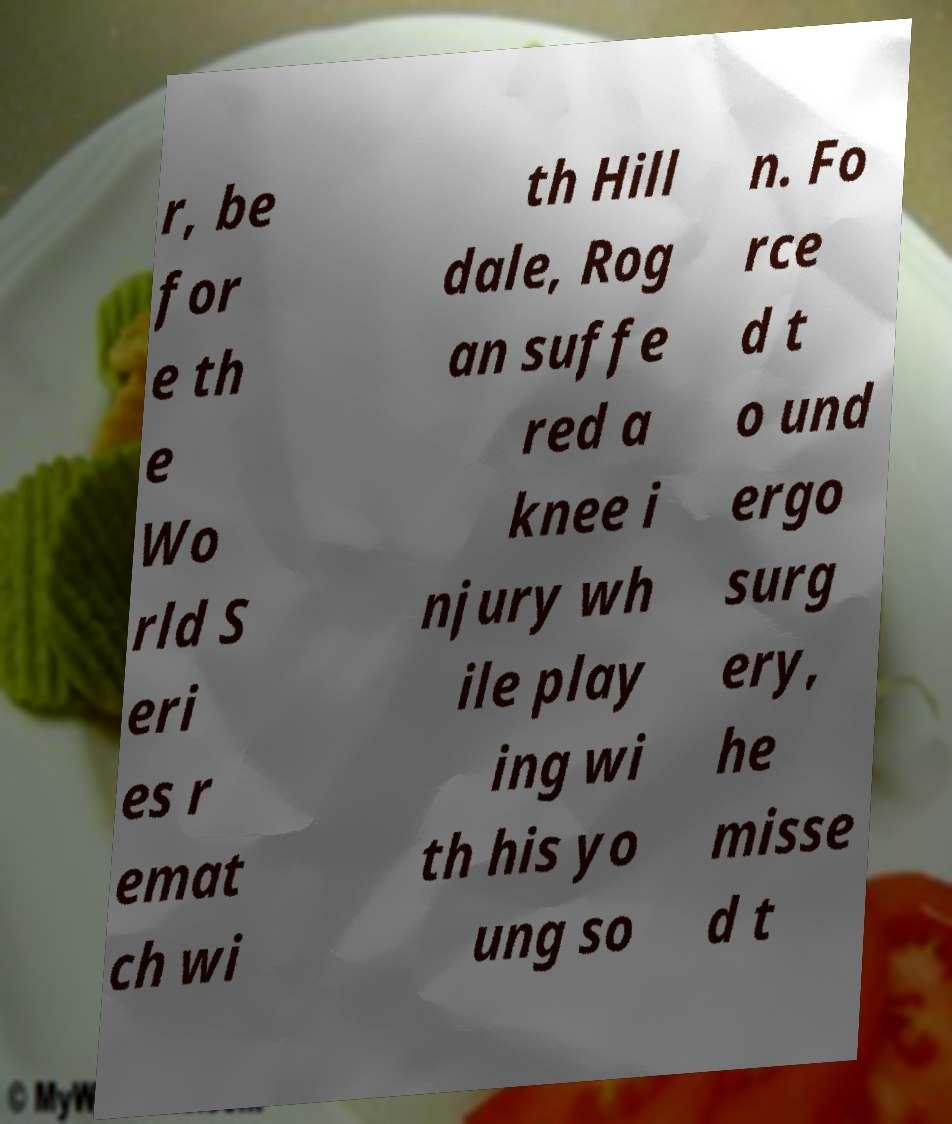Can you accurately transcribe the text from the provided image for me? r, be for e th e Wo rld S eri es r emat ch wi th Hill dale, Rog an suffe red a knee i njury wh ile play ing wi th his yo ung so n. Fo rce d t o und ergo surg ery, he misse d t 